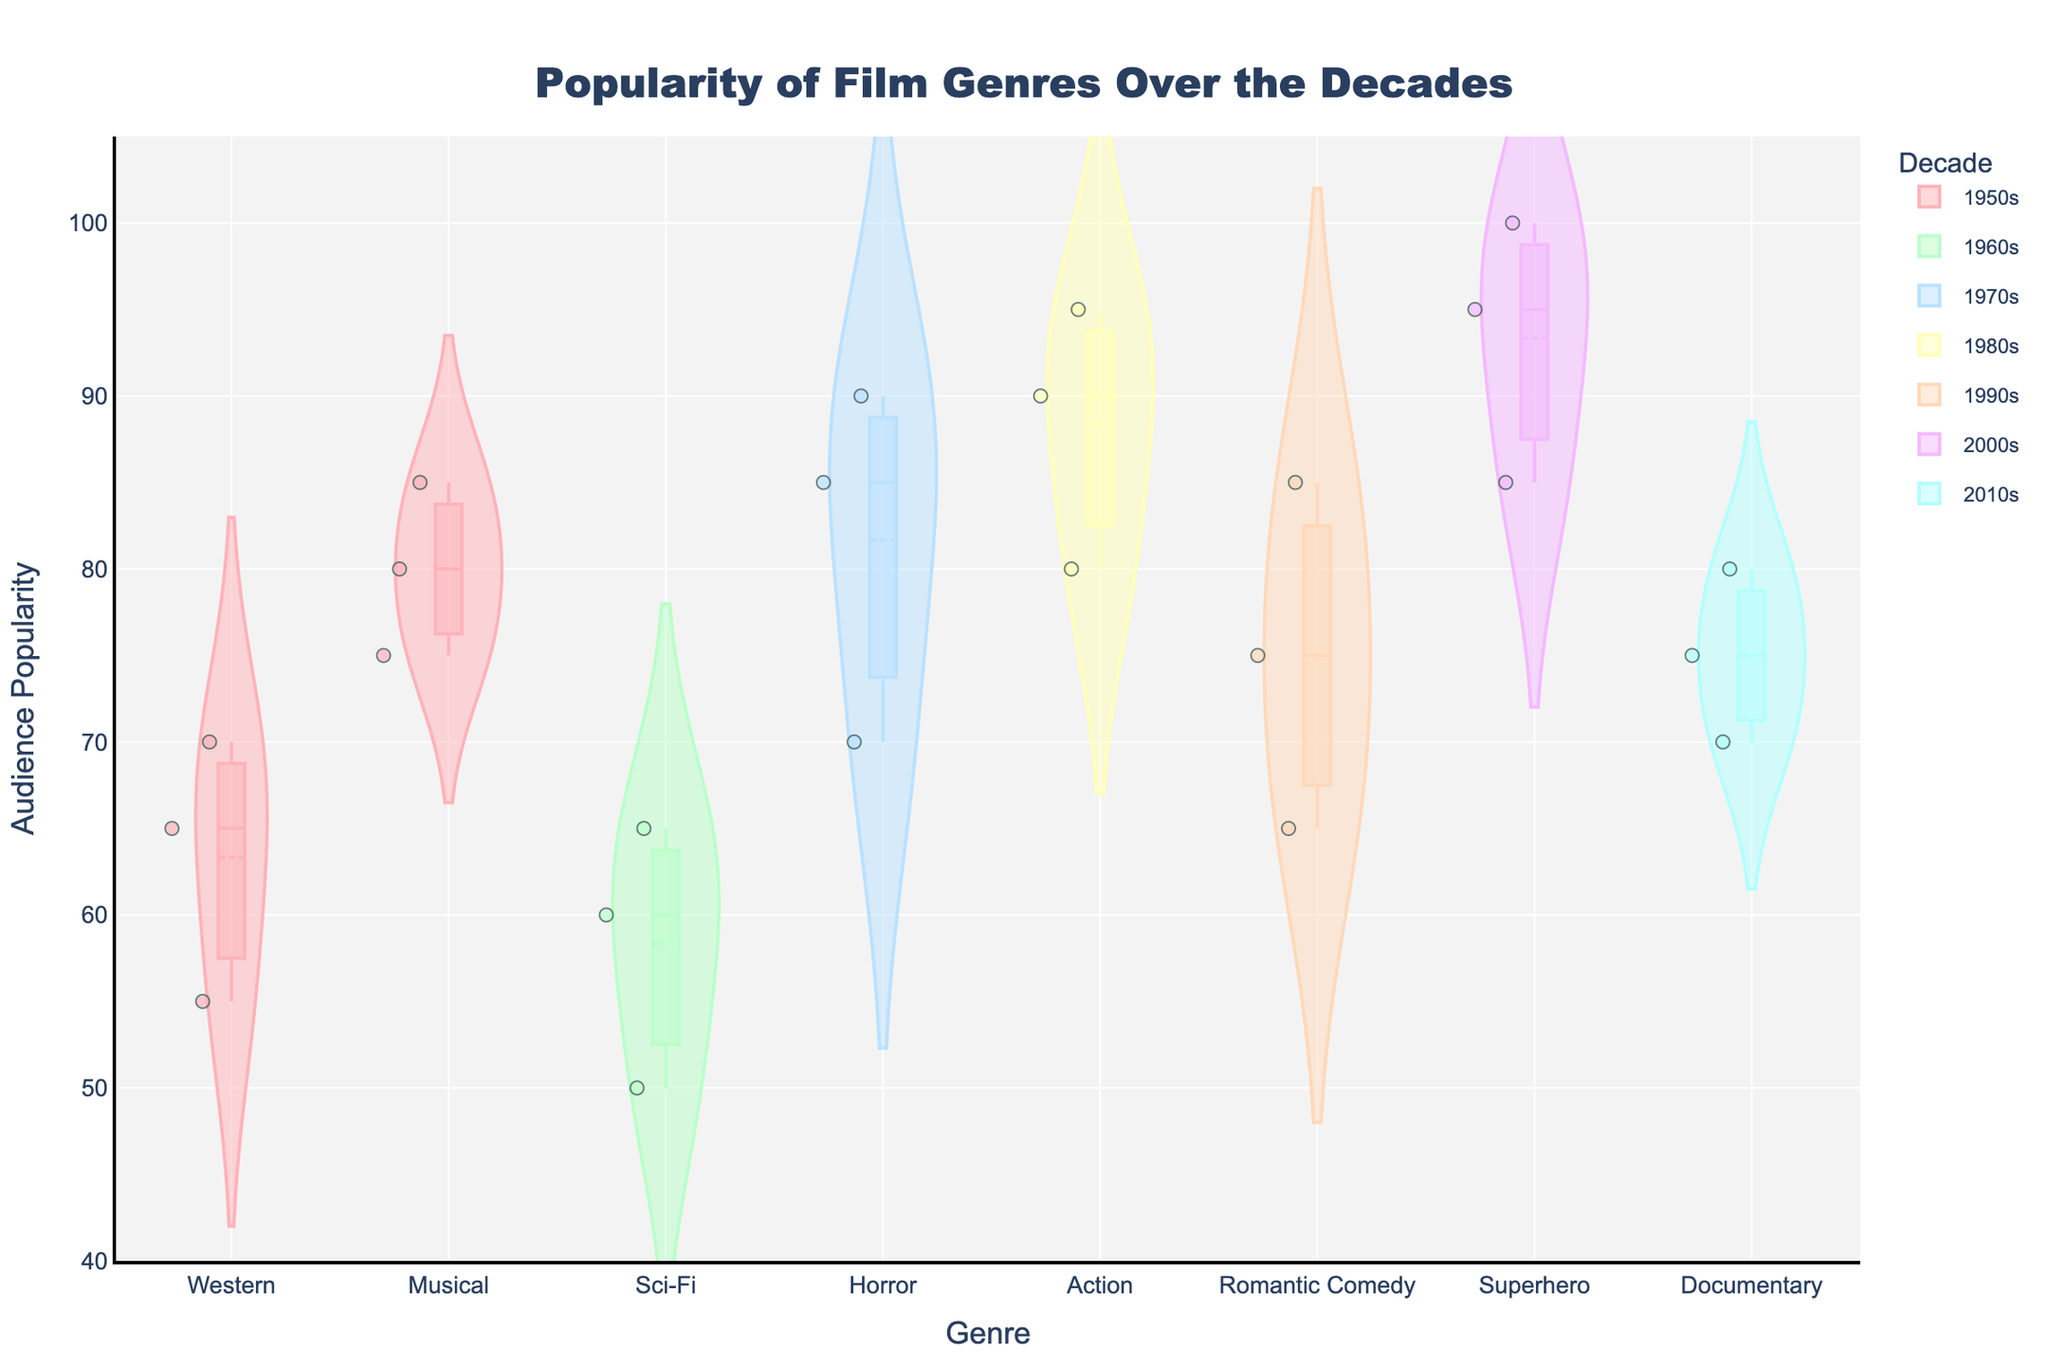What is the title of the figure? The title of the figure is located at the top and usually summarizes the content. Here, the title is "Popularity of Film Genres Over the Decades".
Answer: Popularity of Film Genres Over the Decades Which genre in the 2000s has the highest audience popularity according to the chart? In the 2000s, we can observe the chart and see the genre of "Superhero" showing the highest audience popularity.
Answer: Superhero How does the popularity of Horror in the 1970s compare to Musicals in the 1950s for the 18-25 age group? To compare, observe the violin plot for "Horror" in the 1970s and "Musical" in the 1950s and look at the jittered points for the 18-25 age group. Horror (1970s) is at 90, while Musical (1950s) is at 85.
Answer: Horror (1970s) is more popular What are the popularity ranges for Westerns in the 1950s and Action films in the 1980s? Check the vertical spread of the jittered points and the box plots for the genres. Westerns in the 1950s range from 55 to 70, and Action films in the 1980s range from 80 to 95.
Answer: Westerns: 55-70, Action: 80-95 List the decades in which the documentary genre appears, and for each decade, what is the popularity trend? The Documentary genre appears only in the 2010s. Observe the violin plot; the box plot and jittered points indicate a trend where popularity increases with age from 70 to 80.
Answer: 2010s, increasing trend with age Which genre has the least popularity for the 36-50 age group in the 1960s? Look for the 1960s violin plots and identify the jittered points for 36-50 age group. Sci-Fi in the 1960s has the least popularity, with a score of 50.
Answer: Sci-Fi What is the mean popularity of Musical genre in the 1950s according to the chart? Observe the box plot line in the violin plot of the Musical genre in the 1950s. The mean is represented by a visible central line. Here the mean popularity is around 80.
Answer: 80 Compare the box plot widths of Romantic Comedy in the 1990s and Horror in the 1970s. Which one is wider and what might it indicate? Wider box plots indicate more variability. Look at their respective violin plots and box plots; Romantic Comedy in the 1990s has wider boxes compared to Horror in the 1970s, indicating higher variability in audience popularity.
Answer: Romantic Comedy is wider, higher variability Which age group has the highest popularity for Action films in the 1980s? For Action films in the 1980s, observe the jittered points; the 18-25 age group shows the highest point at 95.
Answer: 18-25 age group What is the general trend of audience popularity for Westerns in the 1950s across different age groups? Check the jittered points for Westerns in the 1950s across different age groups (18-25, 26-35, 36-50). The trend shows a decreasing popularity from 70 to 55 as age increases.
Answer: Decreasing trend 